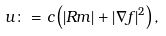Convert formula to latex. <formula><loc_0><loc_0><loc_500><loc_500>u \colon = c \left ( \left | R m \right | + \left | \nabla f \right | ^ { 2 } \right ) ,</formula> 